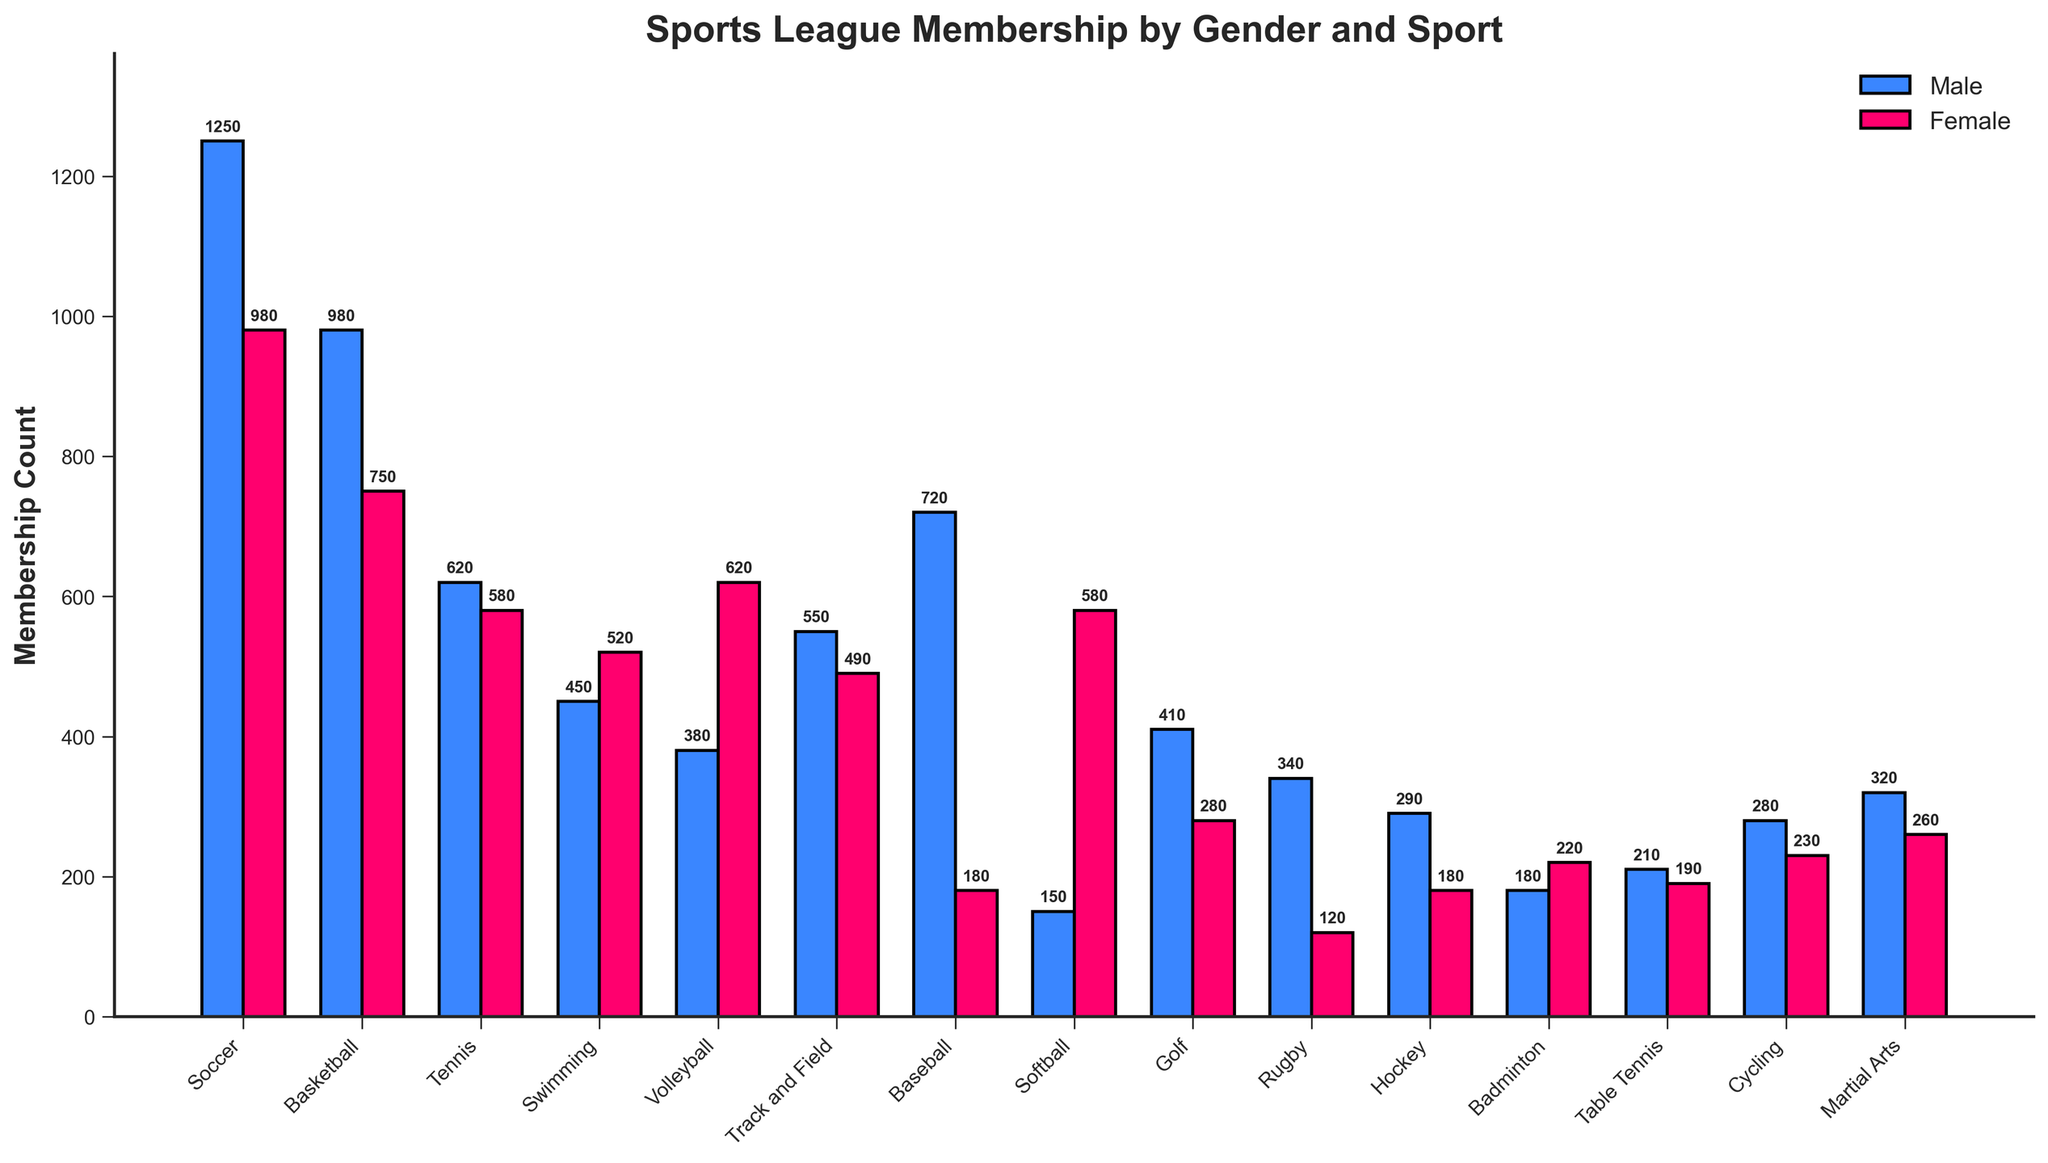Which sport has the highest male membership? By looking at the heights of the blue bars, we can see that Soccer has the highest male membership.
Answer: Soccer Which sport has the highest female membership? By looking at the heights of the red bars, we can see that Volleyball has the highest female membership.
Answer: Volleyball What is the total membership for Rugby? By adding the male and female counts for Rugby (340 + 120), we get the total membership.
Answer: 460 Which sport has a greater difference between male and female membership? The greatest difference can be found by comparing the difference between the male and female bars for each sport. Baseball has the largest difference, where males outnumber females by 720 - 180 = 540.
Answer: Baseball In which sport is female membership greater than male membership? By comparing the heights of the red bars to the blue bars, we can see that Volleyball, Swimming, and Softball have a higher female membership.
Answer: Volleyball, Swimming, Softball Between Tennis and Basketball, which sport has higher total membership? By adding male and female counts for Tennis (620 + 580 = 1200) and Basketball (980 + 750 = 1730), we see Basketball has higher total membership.
Answer: Basketball What is the total number of female members across all sports? By summing the female counts of all sports: 980 + 750 + 580 + 520 + 620 + 490 + 180 + 580 + 280 + 120 + 180 + 220 + 190 + 230 + 260, we get 6200.
Answer: 6200 What is the difference in total membership between Soccer and Volleyball? For Soccer: 1250 + 980 = 2230. For Volleyball: 380 + 620 = 1000. The difference is 2230 - 1000 = 1230.
Answer: 1230 Which has more members: Martial Arts or Hockey? By comparing the total membership of Martial Arts (320 + 260 = 580) and Hockey (290 + 180 = 470), Martial Arts has more members.
Answer: Martial Arts 